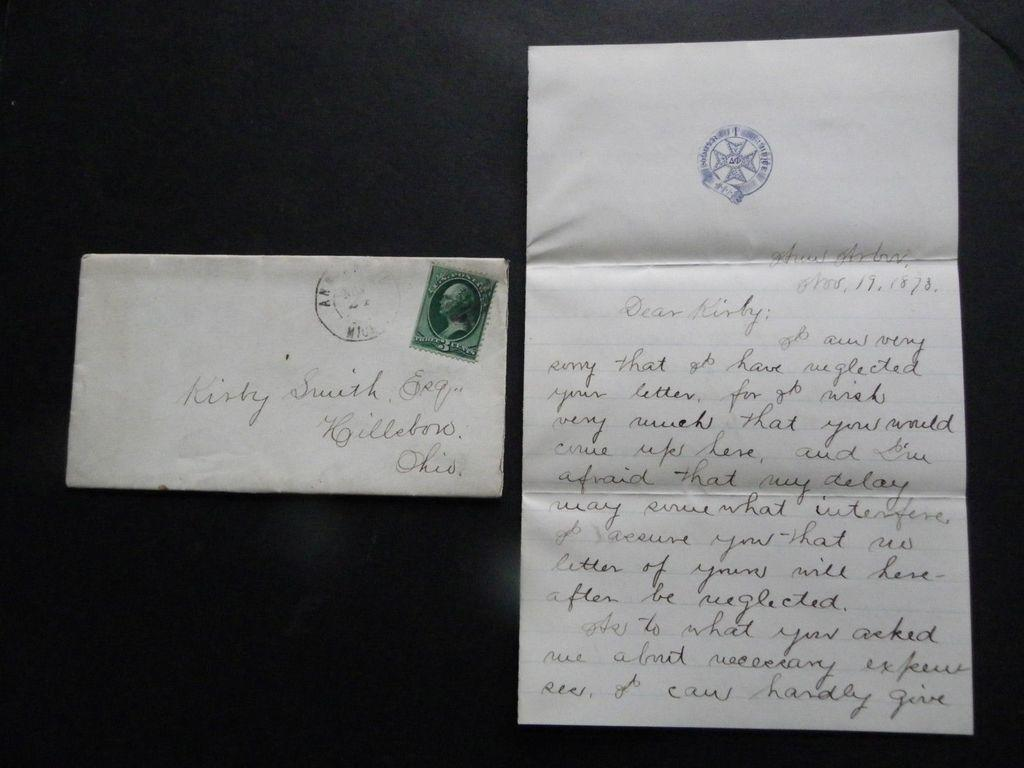<image>
Present a compact description of the photo's key features. A letter sits next to an envelope with a stamp that says 3 cents. 